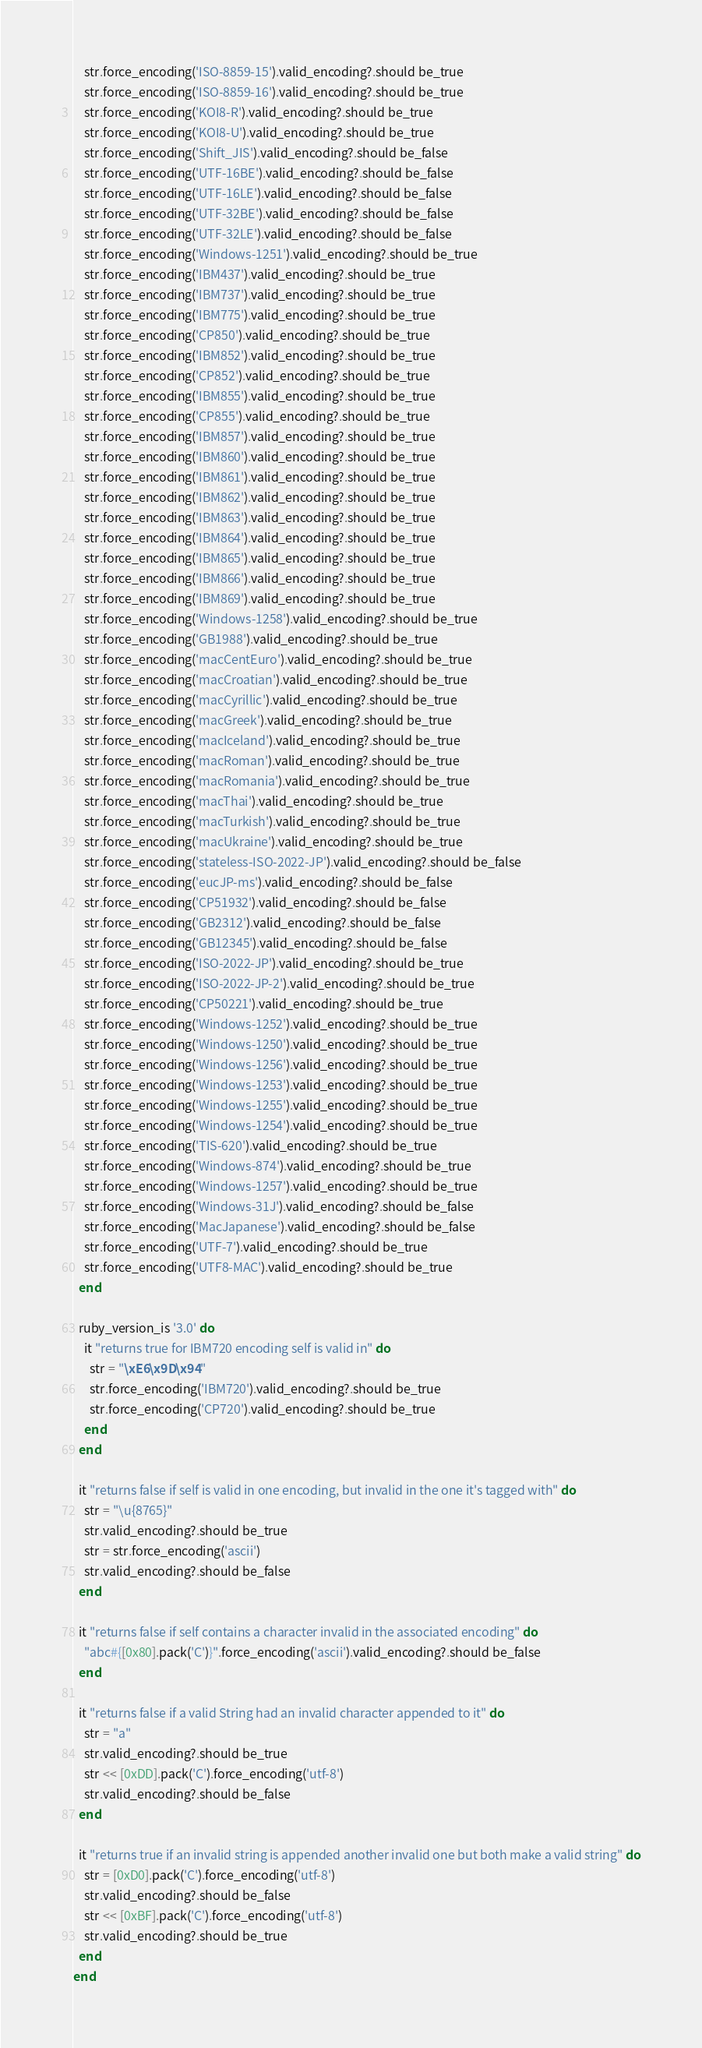<code> <loc_0><loc_0><loc_500><loc_500><_Ruby_>    str.force_encoding('ISO-8859-15').valid_encoding?.should be_true
    str.force_encoding('ISO-8859-16').valid_encoding?.should be_true
    str.force_encoding('KOI8-R').valid_encoding?.should be_true
    str.force_encoding('KOI8-U').valid_encoding?.should be_true
    str.force_encoding('Shift_JIS').valid_encoding?.should be_false
    str.force_encoding('UTF-16BE').valid_encoding?.should be_false
    str.force_encoding('UTF-16LE').valid_encoding?.should be_false
    str.force_encoding('UTF-32BE').valid_encoding?.should be_false
    str.force_encoding('UTF-32LE').valid_encoding?.should be_false
    str.force_encoding('Windows-1251').valid_encoding?.should be_true
    str.force_encoding('IBM437').valid_encoding?.should be_true
    str.force_encoding('IBM737').valid_encoding?.should be_true
    str.force_encoding('IBM775').valid_encoding?.should be_true
    str.force_encoding('CP850').valid_encoding?.should be_true
    str.force_encoding('IBM852').valid_encoding?.should be_true
    str.force_encoding('CP852').valid_encoding?.should be_true
    str.force_encoding('IBM855').valid_encoding?.should be_true
    str.force_encoding('CP855').valid_encoding?.should be_true
    str.force_encoding('IBM857').valid_encoding?.should be_true
    str.force_encoding('IBM860').valid_encoding?.should be_true
    str.force_encoding('IBM861').valid_encoding?.should be_true
    str.force_encoding('IBM862').valid_encoding?.should be_true
    str.force_encoding('IBM863').valid_encoding?.should be_true
    str.force_encoding('IBM864').valid_encoding?.should be_true
    str.force_encoding('IBM865').valid_encoding?.should be_true
    str.force_encoding('IBM866').valid_encoding?.should be_true
    str.force_encoding('IBM869').valid_encoding?.should be_true
    str.force_encoding('Windows-1258').valid_encoding?.should be_true
    str.force_encoding('GB1988').valid_encoding?.should be_true
    str.force_encoding('macCentEuro').valid_encoding?.should be_true
    str.force_encoding('macCroatian').valid_encoding?.should be_true
    str.force_encoding('macCyrillic').valid_encoding?.should be_true
    str.force_encoding('macGreek').valid_encoding?.should be_true
    str.force_encoding('macIceland').valid_encoding?.should be_true
    str.force_encoding('macRoman').valid_encoding?.should be_true
    str.force_encoding('macRomania').valid_encoding?.should be_true
    str.force_encoding('macThai').valid_encoding?.should be_true
    str.force_encoding('macTurkish').valid_encoding?.should be_true
    str.force_encoding('macUkraine').valid_encoding?.should be_true
    str.force_encoding('stateless-ISO-2022-JP').valid_encoding?.should be_false
    str.force_encoding('eucJP-ms').valid_encoding?.should be_false
    str.force_encoding('CP51932').valid_encoding?.should be_false
    str.force_encoding('GB2312').valid_encoding?.should be_false
    str.force_encoding('GB12345').valid_encoding?.should be_false
    str.force_encoding('ISO-2022-JP').valid_encoding?.should be_true
    str.force_encoding('ISO-2022-JP-2').valid_encoding?.should be_true
    str.force_encoding('CP50221').valid_encoding?.should be_true
    str.force_encoding('Windows-1252').valid_encoding?.should be_true
    str.force_encoding('Windows-1250').valid_encoding?.should be_true
    str.force_encoding('Windows-1256').valid_encoding?.should be_true
    str.force_encoding('Windows-1253').valid_encoding?.should be_true
    str.force_encoding('Windows-1255').valid_encoding?.should be_true
    str.force_encoding('Windows-1254').valid_encoding?.should be_true
    str.force_encoding('TIS-620').valid_encoding?.should be_true
    str.force_encoding('Windows-874').valid_encoding?.should be_true
    str.force_encoding('Windows-1257').valid_encoding?.should be_true
    str.force_encoding('Windows-31J').valid_encoding?.should be_false
    str.force_encoding('MacJapanese').valid_encoding?.should be_false
    str.force_encoding('UTF-7').valid_encoding?.should be_true
    str.force_encoding('UTF8-MAC').valid_encoding?.should be_true
  end

  ruby_version_is '3.0' do
    it "returns true for IBM720 encoding self is valid in" do
      str = "\xE6\x9D\x94"
      str.force_encoding('IBM720').valid_encoding?.should be_true
      str.force_encoding('CP720').valid_encoding?.should be_true
    end
  end

  it "returns false if self is valid in one encoding, but invalid in the one it's tagged with" do
    str = "\u{8765}"
    str.valid_encoding?.should be_true
    str = str.force_encoding('ascii')
    str.valid_encoding?.should be_false
  end

  it "returns false if self contains a character invalid in the associated encoding" do
    "abc#{[0x80].pack('C')}".force_encoding('ascii').valid_encoding?.should be_false
  end

  it "returns false if a valid String had an invalid character appended to it" do
    str = "a"
    str.valid_encoding?.should be_true
    str << [0xDD].pack('C').force_encoding('utf-8')
    str.valid_encoding?.should be_false
  end

  it "returns true if an invalid string is appended another invalid one but both make a valid string" do
    str = [0xD0].pack('C').force_encoding('utf-8')
    str.valid_encoding?.should be_false
    str << [0xBF].pack('C').force_encoding('utf-8')
    str.valid_encoding?.should be_true
  end
end
</code> 